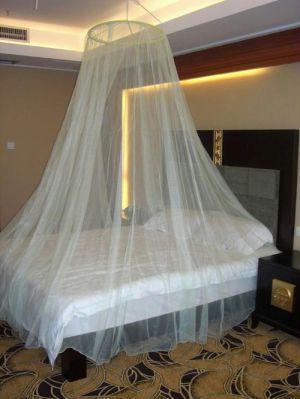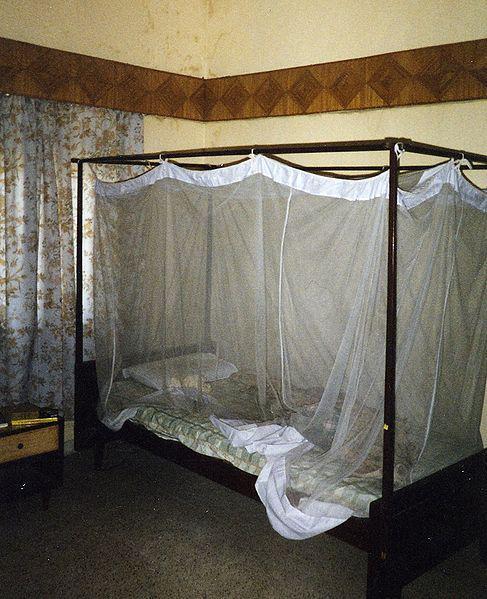The first image is the image on the left, the second image is the image on the right. Examine the images to the left and right. Is the description "There is a round tent and a square tent." accurate? Answer yes or no. No. 